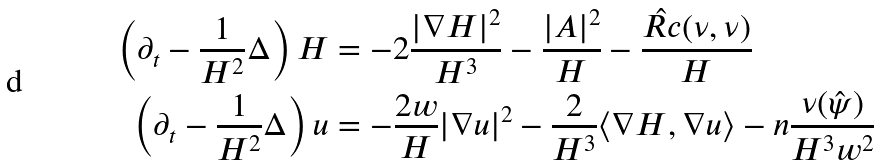Convert formula to latex. <formula><loc_0><loc_0><loc_500><loc_500>\left ( \partial _ { t } - \frac { 1 } { H ^ { 2 } } \Delta \right ) H & = - 2 \frac { | \nabla H | ^ { 2 } } { H ^ { 3 } } - \frac { | A | ^ { 2 } } { H } - \frac { \hat { R c } ( \nu , \nu ) } { H } \\ \left ( \partial _ { t } - \frac { 1 } { H ^ { 2 } } \Delta \right ) u & = - \frac { 2 w } { H } | \nabla u | ^ { 2 } - \frac { 2 } { H ^ { 3 } } \langle \nabla H , \nabla u \rangle - n \frac { \nu ( \hat { \psi } ) } { H ^ { 3 } w ^ { 2 } }</formula> 